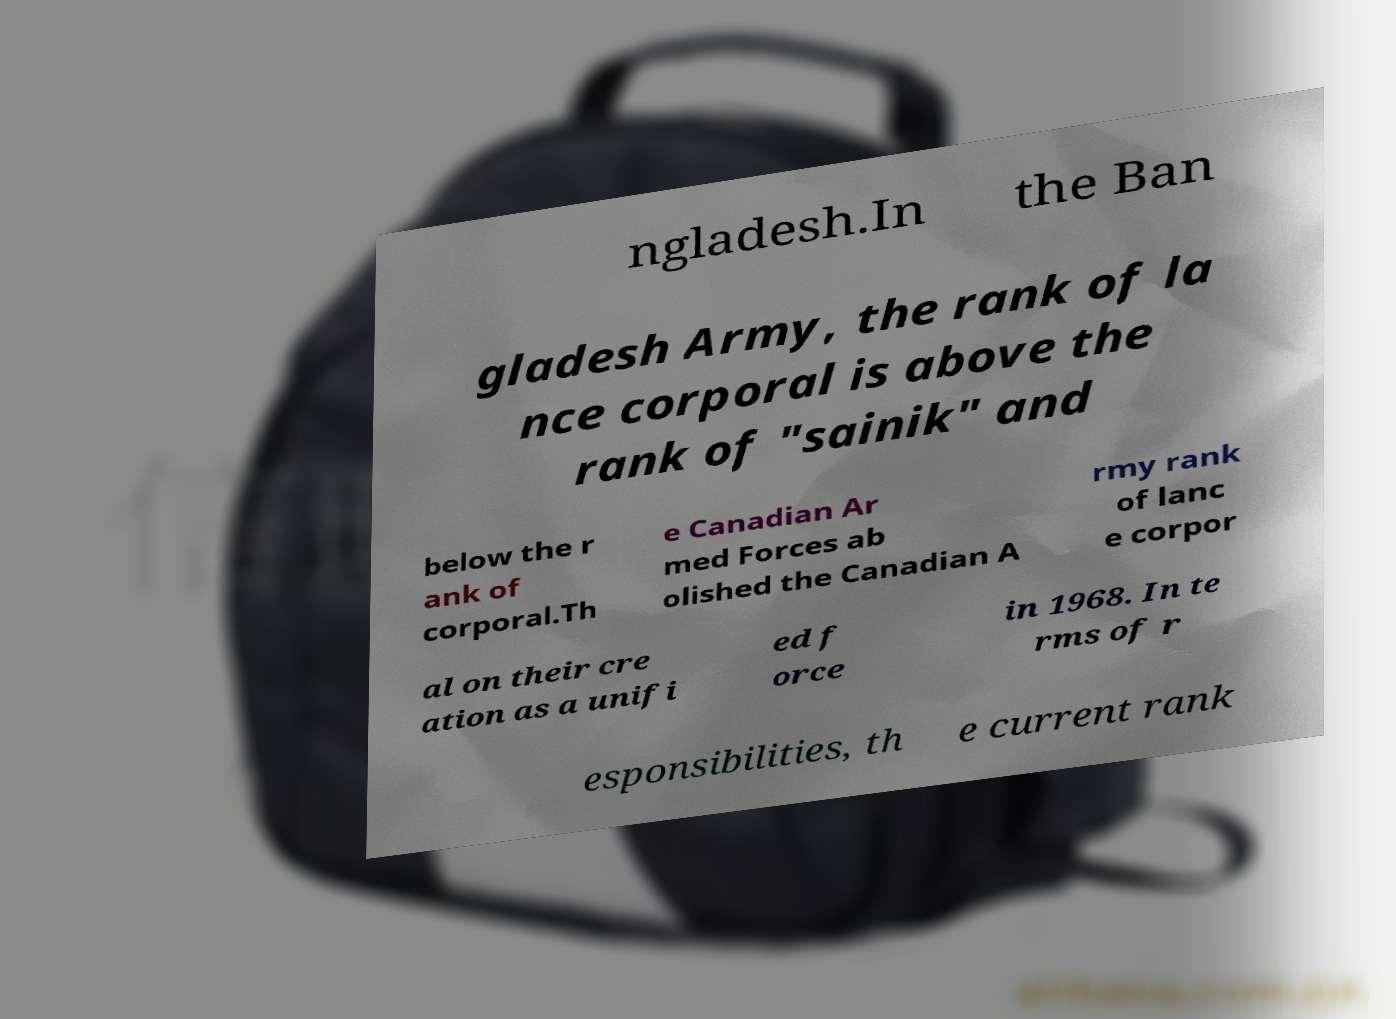There's text embedded in this image that I need extracted. Can you transcribe it verbatim? ngladesh.In the Ban gladesh Army, the rank of la nce corporal is above the rank of "sainik" and below the r ank of corporal.Th e Canadian Ar med Forces ab olished the Canadian A rmy rank of lanc e corpor al on their cre ation as a unifi ed f orce in 1968. In te rms of r esponsibilities, th e current rank 